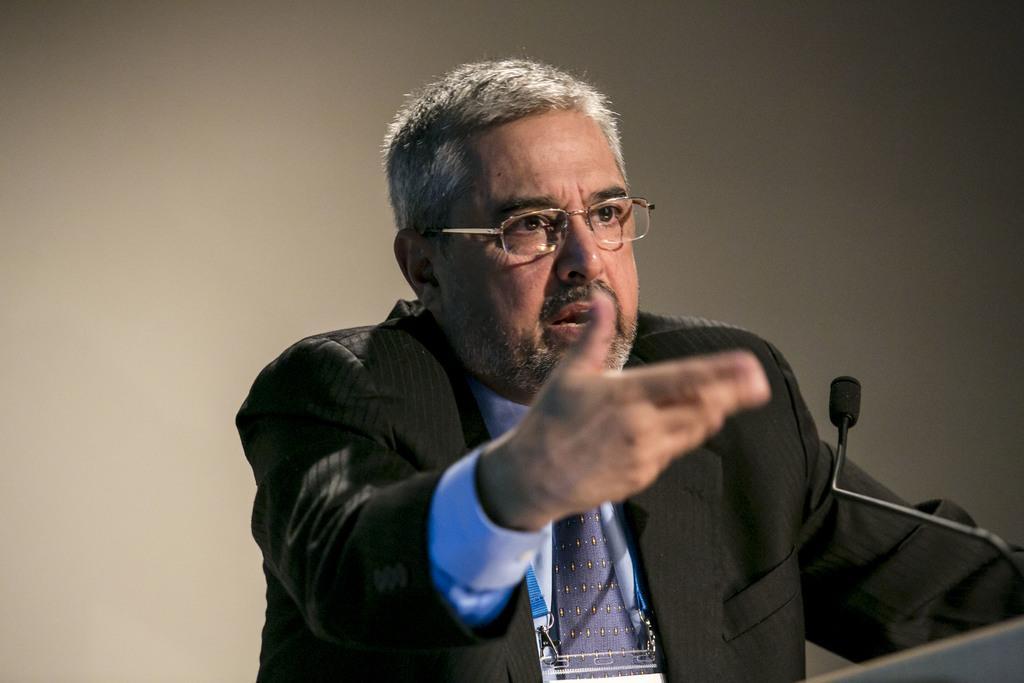In one or two sentences, can you explain what this image depicts? On the right side, there is a person in a suit, wearing a spectacle and speaking in front of a mic. Which is attached to a stand. In the background, there is a white color surface. 